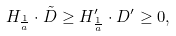Convert formula to latex. <formula><loc_0><loc_0><loc_500><loc_500>H _ { \frac { 1 } { a } } \cdot \tilde { D } \geq H ^ { \prime } _ { \frac { 1 } { a } } \cdot D ^ { \prime } \geq 0 ,</formula> 